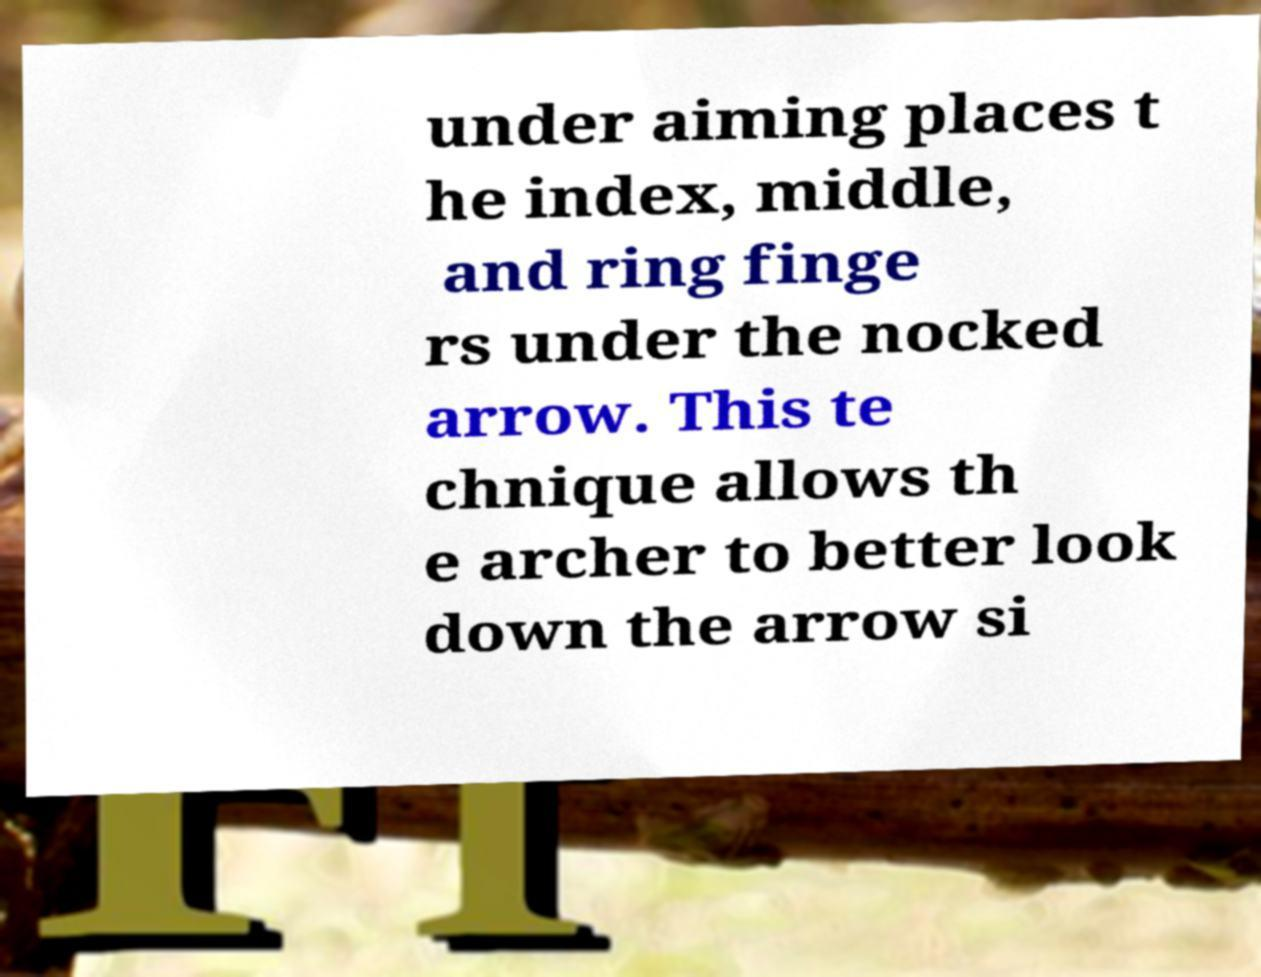Can you read and provide the text displayed in the image?This photo seems to have some interesting text. Can you extract and type it out for me? under aiming places t he index, middle, and ring finge rs under the nocked arrow. This te chnique allows th e archer to better look down the arrow si 